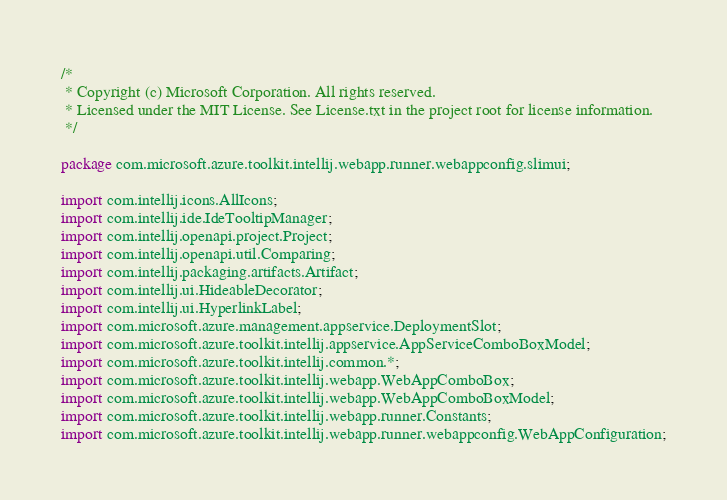Convert code to text. <code><loc_0><loc_0><loc_500><loc_500><_Java_>/*
 * Copyright (c) Microsoft Corporation. All rights reserved.
 * Licensed under the MIT License. See License.txt in the project root for license information.
 */

package com.microsoft.azure.toolkit.intellij.webapp.runner.webappconfig.slimui;

import com.intellij.icons.AllIcons;
import com.intellij.ide.IdeTooltipManager;
import com.intellij.openapi.project.Project;
import com.intellij.openapi.util.Comparing;
import com.intellij.packaging.artifacts.Artifact;
import com.intellij.ui.HideableDecorator;
import com.intellij.ui.HyperlinkLabel;
import com.microsoft.azure.management.appservice.DeploymentSlot;
import com.microsoft.azure.toolkit.intellij.appservice.AppServiceComboBoxModel;
import com.microsoft.azure.toolkit.intellij.common.*;
import com.microsoft.azure.toolkit.intellij.webapp.WebAppComboBox;
import com.microsoft.azure.toolkit.intellij.webapp.WebAppComboBoxModel;
import com.microsoft.azure.toolkit.intellij.webapp.runner.Constants;
import com.microsoft.azure.toolkit.intellij.webapp.runner.webappconfig.WebAppConfiguration;</code> 